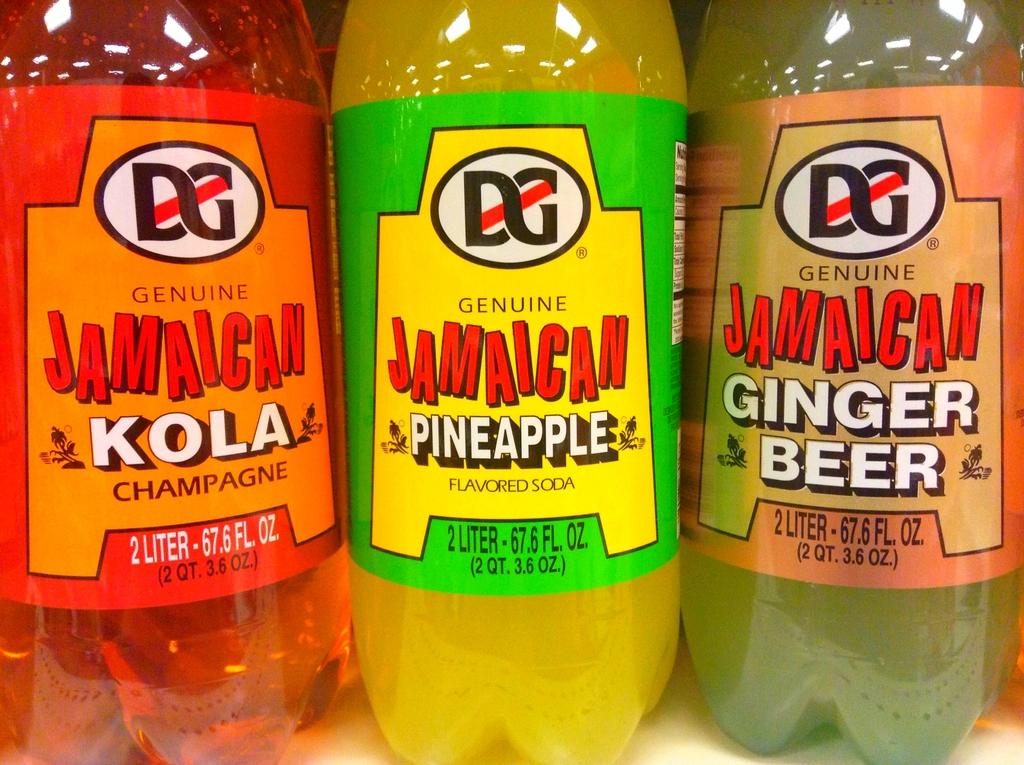<image>
Create a compact narrative representing the image presented. Three soda bottles of different flavors, one that says Pineapple. 